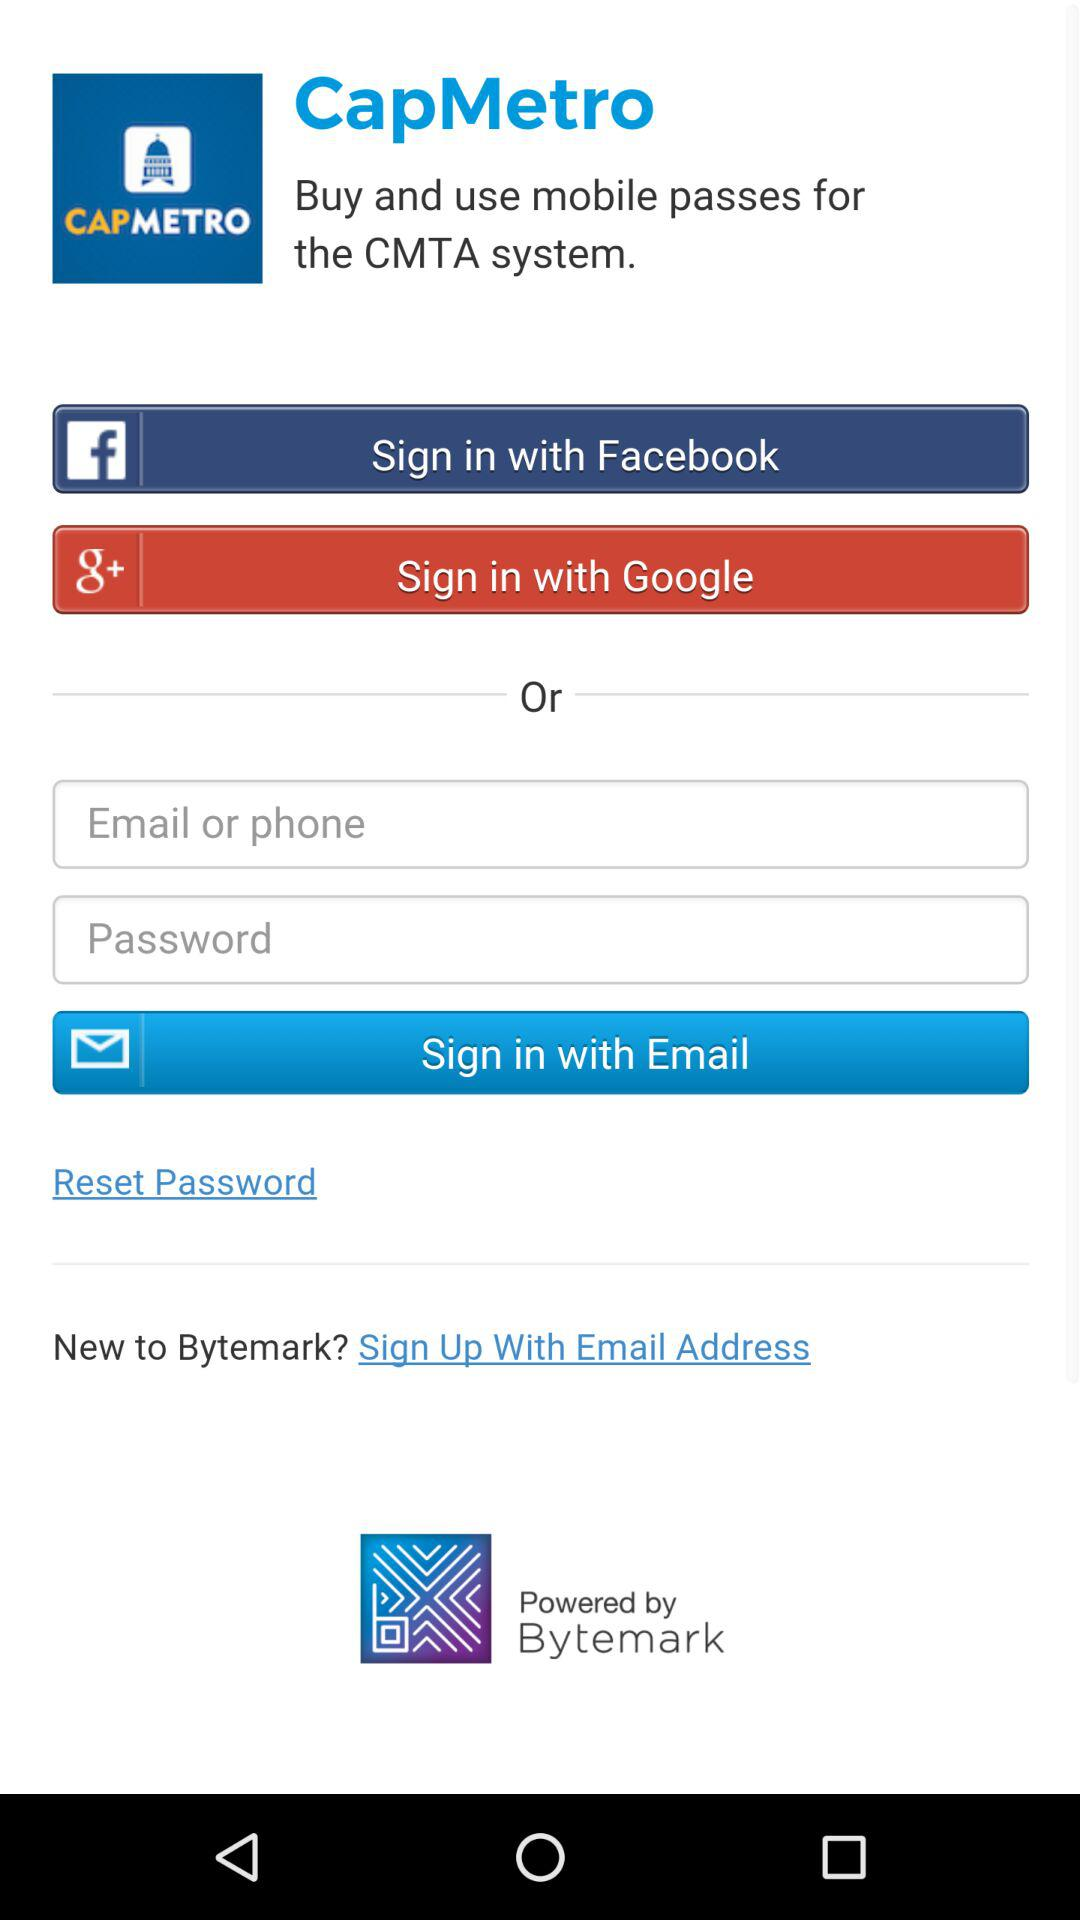What are the different ways to sign in? The different ways to sign in are "Facebook", "Google" and "Email". 